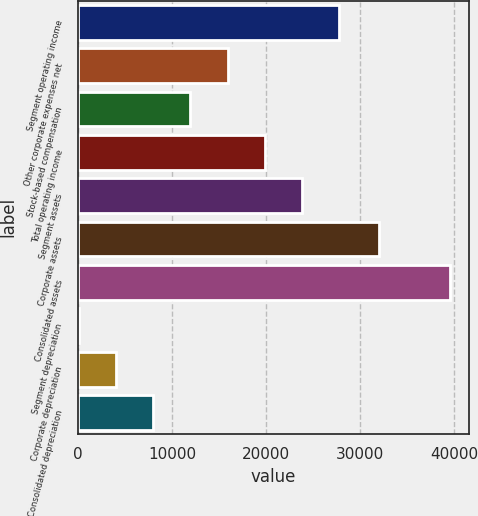Convert chart. <chart><loc_0><loc_0><loc_500><loc_500><bar_chart><fcel>Segment operating income<fcel>Other corporate expenses net<fcel>Stock-based compensation<fcel>Total operating income<fcel>Segment assets<fcel>Corporate assets<fcel>Consolidated assets<fcel>Segment depreciation<fcel>Corporate depreciation<fcel>Consolidated depreciation<nl><fcel>27739.1<fcel>15906.2<fcel>11961.9<fcel>19850.5<fcel>23794.8<fcel>32053<fcel>39572<fcel>129<fcel>4073.3<fcel>8017.6<nl></chart> 